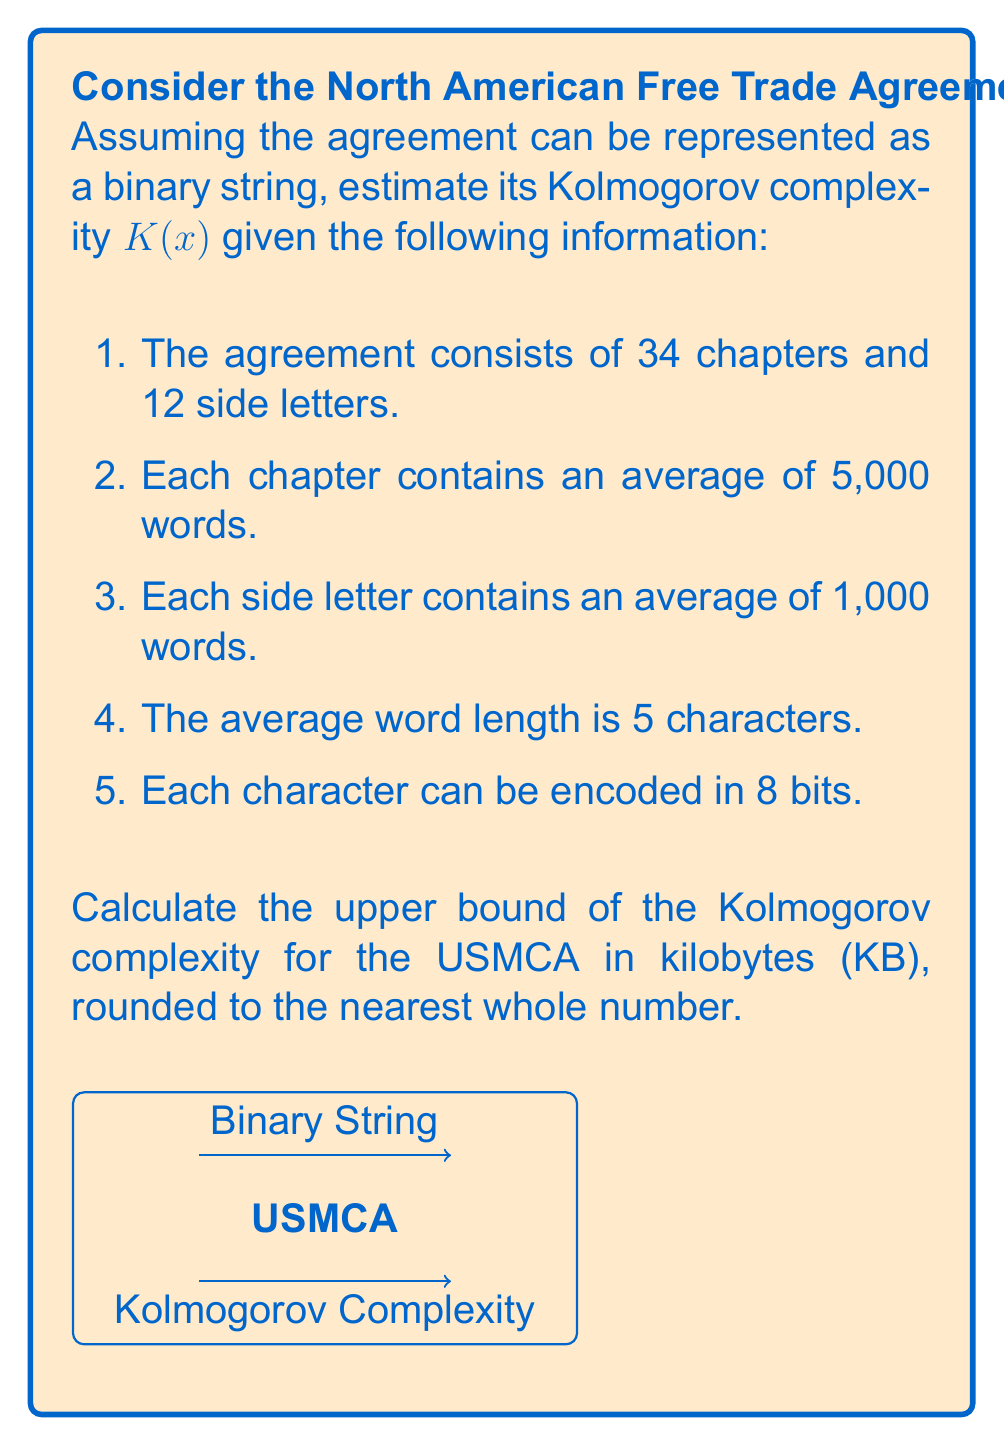What is the answer to this math problem? Let's approach this step-by-step:

1. Calculate the total number of words in the agreement:
   - Chapters: $34 \times 5,000 = 170,000$ words
   - Side letters: $12 \times 1,000 = 12,000$ words
   - Total words: $170,000 + 12,000 = 182,000$ words

2. Calculate the total number of characters:
   $182,000 \times 5 = 910,000$ characters

3. Calculate the total number of bits:
   $910,000 \times 8 = 7,280,000$ bits

4. Convert bits to bytes:
   $7,280,000 \div 8 = 910,000$ bytes

5. Convert bytes to kilobytes:
   $910,000 \div 1024 \approx 888.67$ KB

6. Round to the nearest whole number:
   $889$ KB

The Kolmogorov complexity $K(x)$ is defined as the length of the shortest program that produces the string $x$ as output. In this case, we don't know the actual shortest program, but we know that it cannot be longer than the string itself (otherwise, we could just use the string as the program).

Therefore, the upper bound of the Kolmogorov complexity is the length of the string itself, which we calculated as 889 KB.

It's important to note that this is a very conservative upper bound. The actual Kolmogorov complexity is likely much lower due to the repetitive nature of legal documents and the structure of trade agreements.
Answer: $K(x) \leq 889$ KB 